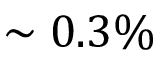Convert formula to latex. <formula><loc_0><loc_0><loc_500><loc_500>\sim 0 . 3 \%</formula> 